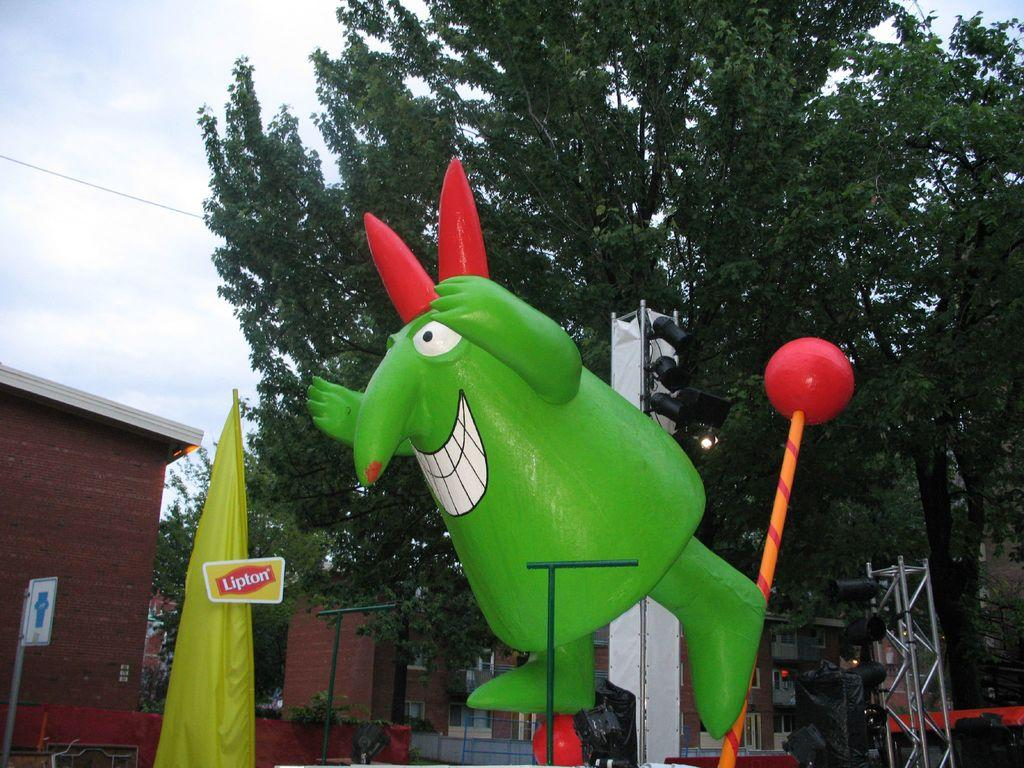What is the main subject of the image? There is a statue of a cartoon in the image. What can be seen behind the statue? There is stage equipment behind the statue. What is visible in the background of the image? There are buildings and trees in the background of the image. What is visible at the top of the image? The sky is visible in the image, and clouds are present in the sky. What type of dress is the secretary wearing in the image? There is no secretary present in the image; it features a statue of a cartoon and other elements in the background. 